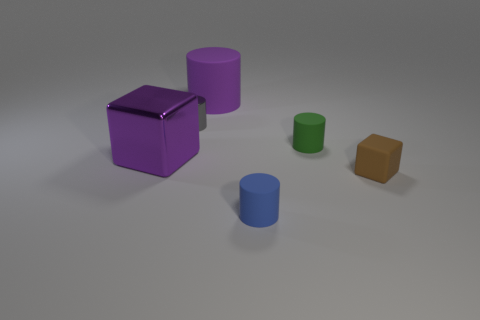Subtract all purple cylinders. How many cylinders are left? 3 Subtract all rubber cylinders. How many cylinders are left? 1 Subtract all cyan cylinders. Subtract all purple balls. How many cylinders are left? 4 Add 2 tiny blue things. How many objects exist? 8 Add 6 big metallic spheres. How many big metallic spheres exist? 6 Subtract 0 gray balls. How many objects are left? 6 Subtract all cylinders. How many objects are left? 2 Subtract all purple things. Subtract all tiny cylinders. How many objects are left? 1 Add 1 tiny things. How many tiny things are left? 5 